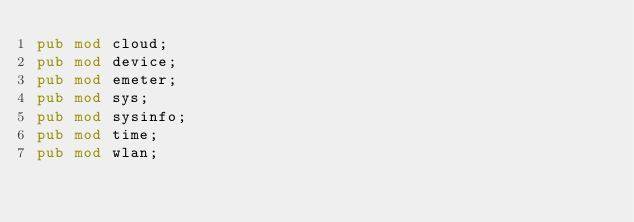Convert code to text. <code><loc_0><loc_0><loc_500><loc_500><_Rust_>pub mod cloud;
pub mod device;
pub mod emeter;
pub mod sys;
pub mod sysinfo;
pub mod time;
pub mod wlan;
</code> 